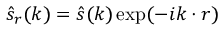<formula> <loc_0><loc_0><loc_500><loc_500>\hat { s } _ { r } ( \boldsymbol k ) = \hat { s } ( \boldsymbol k ) \exp ( - i \boldsymbol k \cdot \boldsymbol r )</formula> 